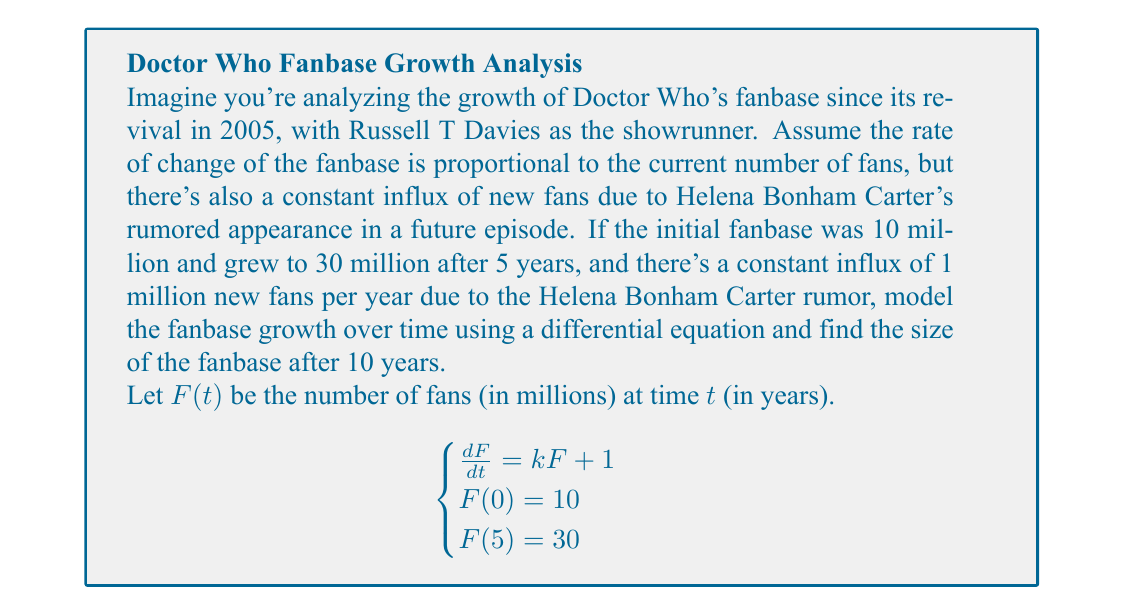Give your solution to this math problem. 1) We start with the differential equation:
   $$\frac{dF}{dt} = kF + 1$$

2) This is a first-order linear differential equation. The general solution is:
   $$F(t) = Ce^{kt} - \frac{1}{k}$$

3) Using the initial condition $F(0) = 10$:
   $$10 = Ce^{k(0)} - \frac{1}{k}$$
   $$C = 10 + \frac{1}{k}$$

4) Substituting this back into the general solution:
   $$F(t) = (10 + \frac{1}{k})e^{kt} - \frac{1}{k}$$

5) Now use the condition $F(5) = 30$:
   $$30 = (10 + \frac{1}{k})e^{5k} - \frac{1}{k}$$

6) This equation can be solved numerically for $k$. Using a numerical solver, we find:
   $$k \approx 0.2197$$

7) Now we have the complete model:
   $$F(t) = (10 + \frac{1}{0.2197})e^{0.2197t} - \frac{1}{0.2197}$$

8) To find the fanbase after 10 years, we calculate $F(10)$:
   $$F(10) = (10 + \frac{1}{0.2197})e^{0.2197(10)} - \frac{1}{0.2197}$$
   $$F(10) \approx 74.8$$

Therefore, after 10 years, the fanbase would be approximately 74.8 million.
Answer: 74.8 million fans 